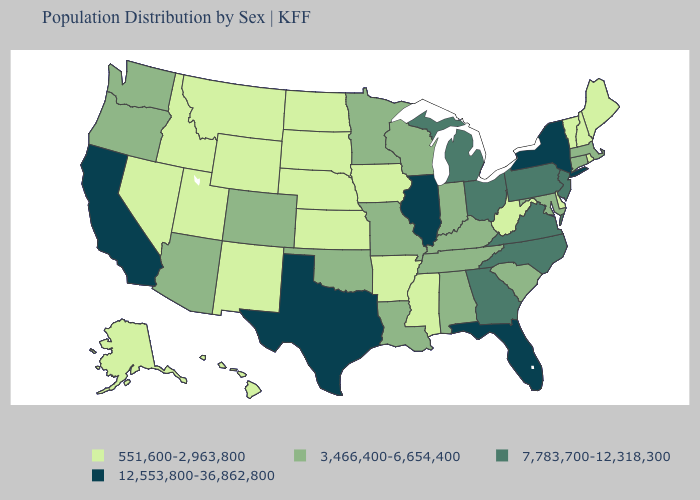What is the highest value in states that border Louisiana?
Give a very brief answer. 12,553,800-36,862,800. Which states have the lowest value in the South?
Concise answer only. Arkansas, Delaware, Mississippi, West Virginia. What is the value of Michigan?
Concise answer only. 7,783,700-12,318,300. Which states have the lowest value in the USA?
Give a very brief answer. Alaska, Arkansas, Delaware, Hawaii, Idaho, Iowa, Kansas, Maine, Mississippi, Montana, Nebraska, Nevada, New Hampshire, New Mexico, North Dakota, Rhode Island, South Dakota, Utah, Vermont, West Virginia, Wyoming. What is the value of Pennsylvania?
Short answer required. 7,783,700-12,318,300. What is the highest value in states that border Utah?
Answer briefly. 3,466,400-6,654,400. Name the states that have a value in the range 7,783,700-12,318,300?
Quick response, please. Georgia, Michigan, New Jersey, North Carolina, Ohio, Pennsylvania, Virginia. What is the highest value in states that border New Hampshire?
Concise answer only. 3,466,400-6,654,400. Which states have the highest value in the USA?
Quick response, please. California, Florida, Illinois, New York, Texas. Does Florida have the highest value in the USA?
Keep it brief. Yes. Which states hav the highest value in the MidWest?
Short answer required. Illinois. Does North Carolina have the same value as New Mexico?
Short answer required. No. Does Arizona have the highest value in the USA?
Quick response, please. No. Name the states that have a value in the range 551,600-2,963,800?
Write a very short answer. Alaska, Arkansas, Delaware, Hawaii, Idaho, Iowa, Kansas, Maine, Mississippi, Montana, Nebraska, Nevada, New Hampshire, New Mexico, North Dakota, Rhode Island, South Dakota, Utah, Vermont, West Virginia, Wyoming. Name the states that have a value in the range 3,466,400-6,654,400?
Concise answer only. Alabama, Arizona, Colorado, Connecticut, Indiana, Kentucky, Louisiana, Maryland, Massachusetts, Minnesota, Missouri, Oklahoma, Oregon, South Carolina, Tennessee, Washington, Wisconsin. 